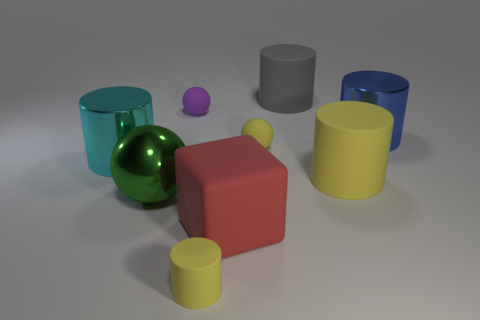Subtract all blue cylinders. How many cylinders are left? 4 Subtract all big cyan metal cylinders. How many cylinders are left? 4 Subtract all brown cylinders. Subtract all yellow balls. How many cylinders are left? 5 Subtract all spheres. How many objects are left? 6 Subtract all big red matte cubes. Subtract all cyan metallic cylinders. How many objects are left? 7 Add 4 yellow objects. How many yellow objects are left? 7 Add 5 green matte cubes. How many green matte cubes exist? 5 Subtract 0 blue cubes. How many objects are left? 9 